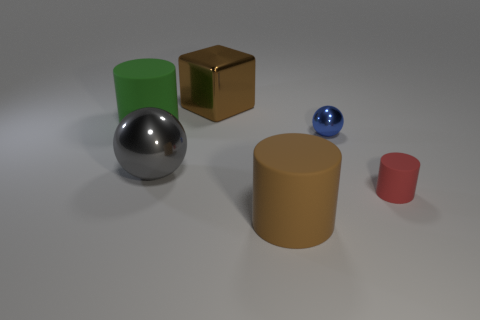Add 4 red objects. How many objects exist? 10 Subtract all cubes. How many objects are left? 5 Add 4 green objects. How many green objects exist? 5 Subtract 0 purple cylinders. How many objects are left? 6 Subtract all big brown cubes. Subtract all big green shiny blocks. How many objects are left? 5 Add 4 green rubber objects. How many green rubber objects are left? 5 